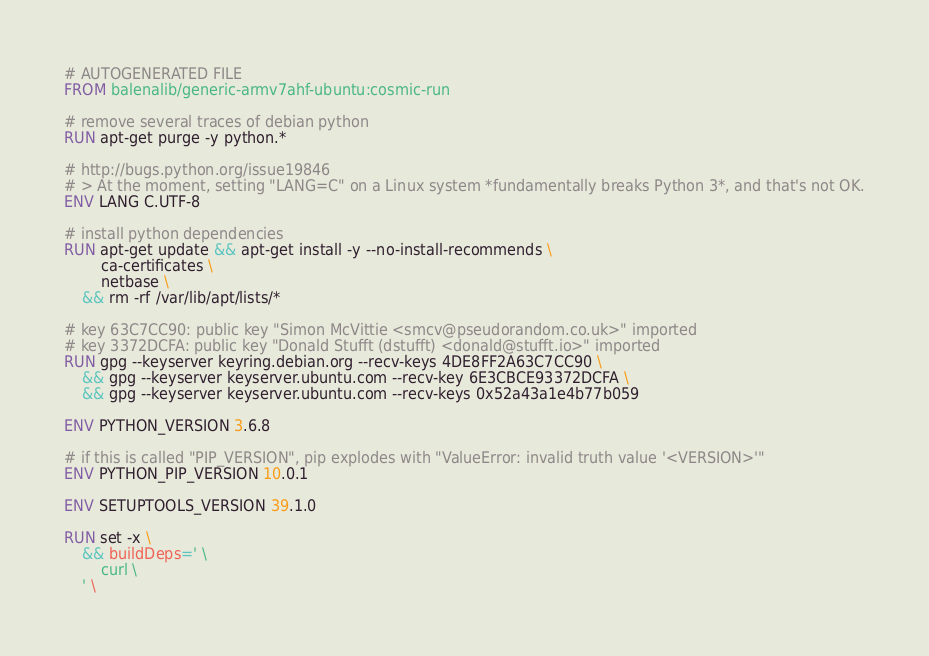<code> <loc_0><loc_0><loc_500><loc_500><_Dockerfile_># AUTOGENERATED FILE
FROM balenalib/generic-armv7ahf-ubuntu:cosmic-run

# remove several traces of debian python
RUN apt-get purge -y python.*

# http://bugs.python.org/issue19846
# > At the moment, setting "LANG=C" on a Linux system *fundamentally breaks Python 3*, and that's not OK.
ENV LANG C.UTF-8

# install python dependencies
RUN apt-get update && apt-get install -y --no-install-recommends \
		ca-certificates \
		netbase \
	&& rm -rf /var/lib/apt/lists/*

# key 63C7CC90: public key "Simon McVittie <smcv@pseudorandom.co.uk>" imported
# key 3372DCFA: public key "Donald Stufft (dstufft) <donald@stufft.io>" imported
RUN gpg --keyserver keyring.debian.org --recv-keys 4DE8FF2A63C7CC90 \
	&& gpg --keyserver keyserver.ubuntu.com --recv-key 6E3CBCE93372DCFA \
	&& gpg --keyserver keyserver.ubuntu.com --recv-keys 0x52a43a1e4b77b059

ENV PYTHON_VERSION 3.6.8

# if this is called "PIP_VERSION", pip explodes with "ValueError: invalid truth value '<VERSION>'"
ENV PYTHON_PIP_VERSION 10.0.1

ENV SETUPTOOLS_VERSION 39.1.0

RUN set -x \
	&& buildDeps=' \
		curl \
	' \</code> 